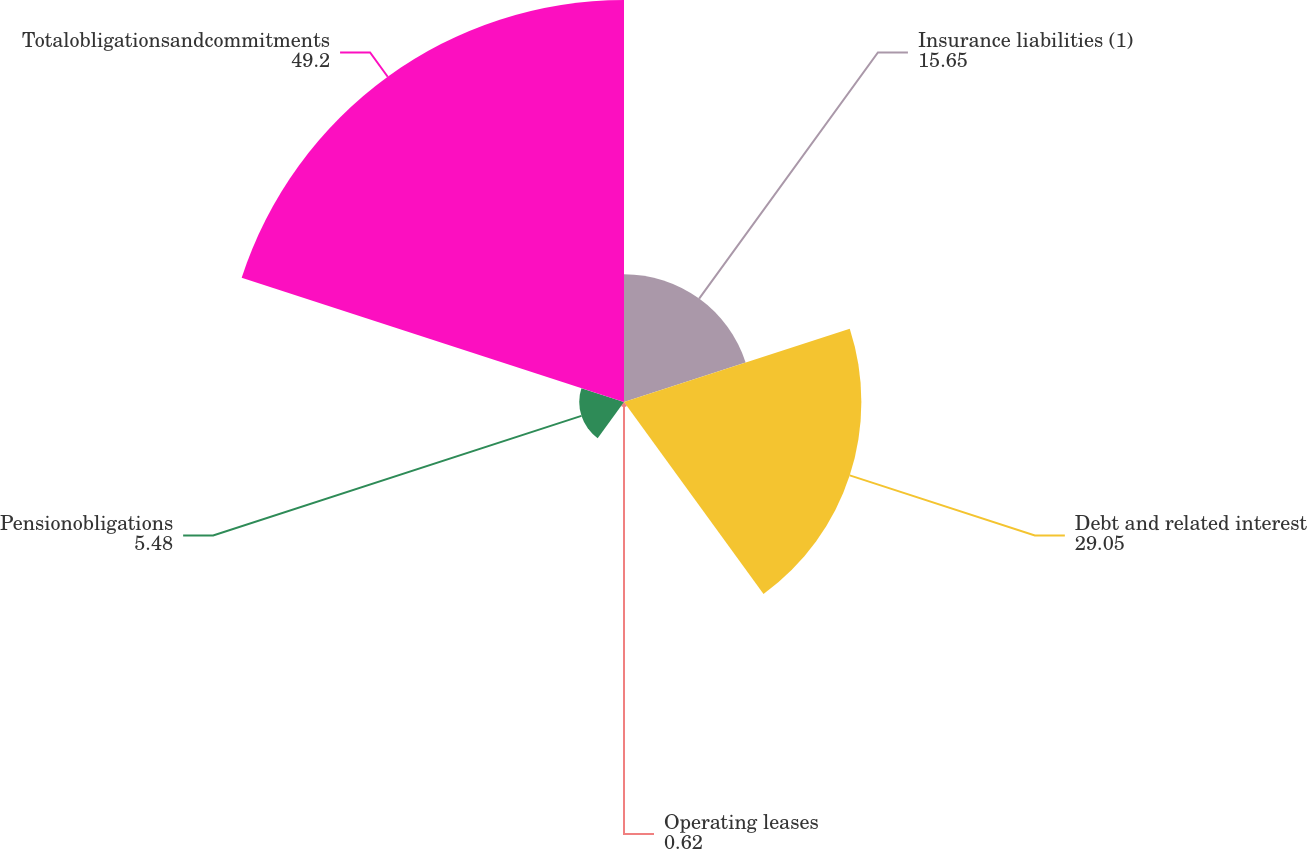Convert chart to OTSL. <chart><loc_0><loc_0><loc_500><loc_500><pie_chart><fcel>Insurance liabilities (1)<fcel>Debt and related interest<fcel>Operating leases<fcel>Pensionobligations<fcel>Totalobligationsandcommitments<nl><fcel>15.65%<fcel>29.05%<fcel>0.62%<fcel>5.48%<fcel>49.2%<nl></chart> 